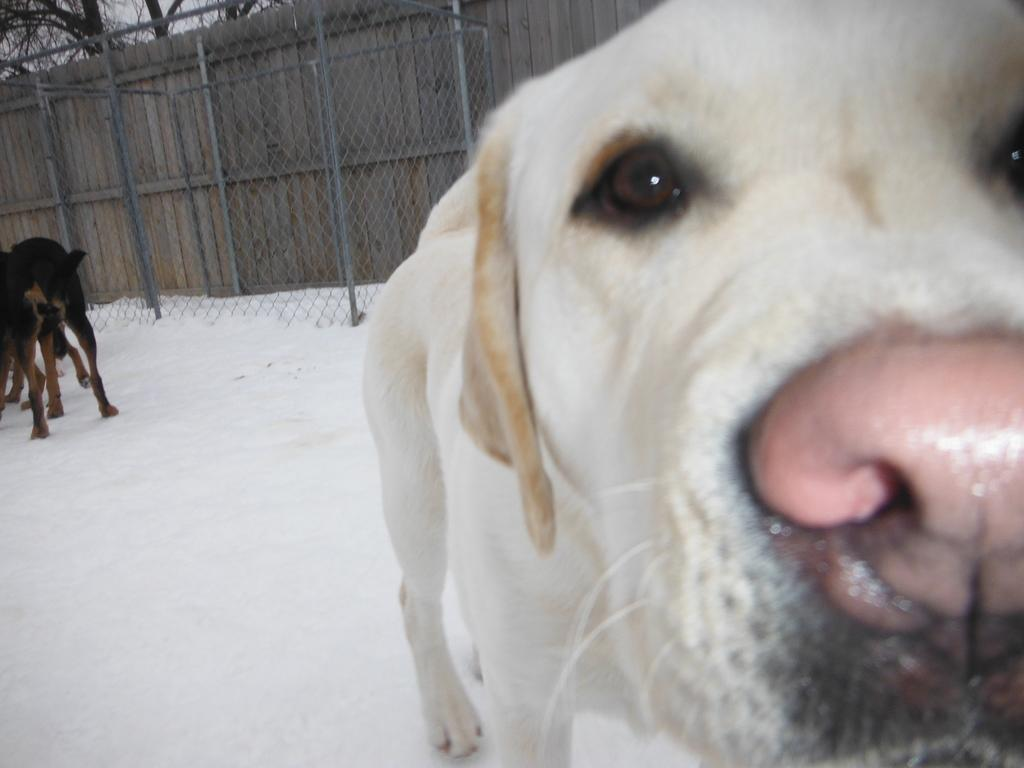What type of animal is on the right side of the image? There is a white dog on the right side of the image. How many dogs are visible in the image? There are other dogs in the image besides the white dog. What can be seen in the background of the image? There is a boundary and trees in the background of the image. What is the condition of the ground in the image? There is snow on the ground in the image. What type of kitty can be seen playing with a bean in the image? There is no kitty or bean present in the image; it features a white dog and other dogs in a snowy environment. 